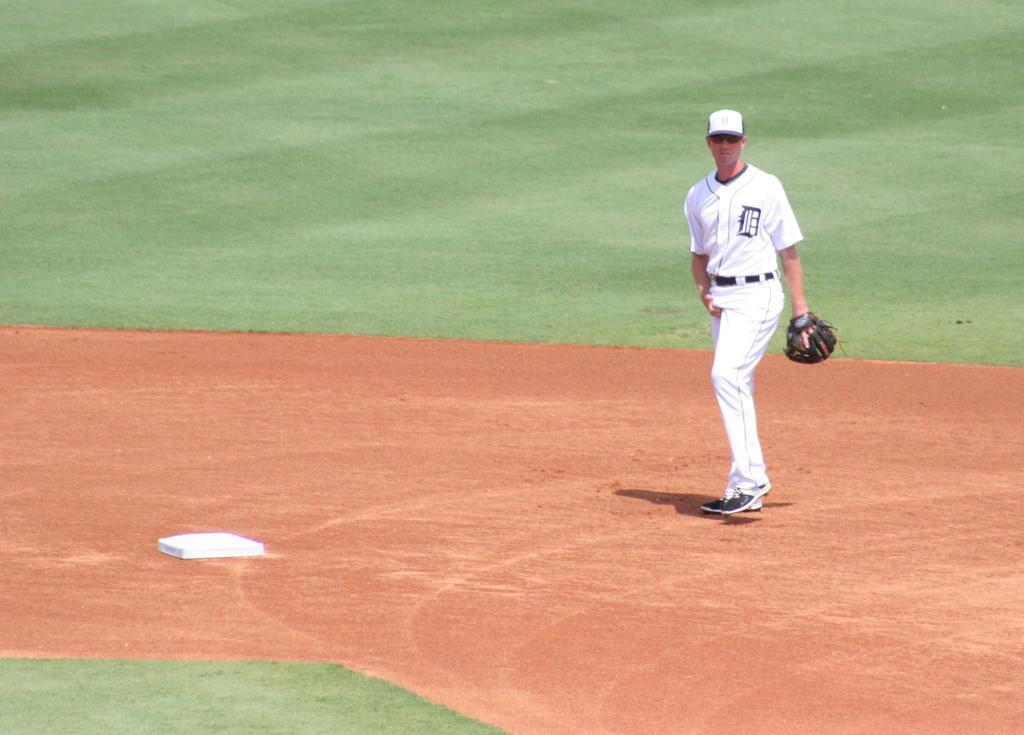In one or two sentences, can you explain what this image depicts? In the foreground of this image, there is a man in white dress walking on the ground. In the background, and bottom of the image having grass. 